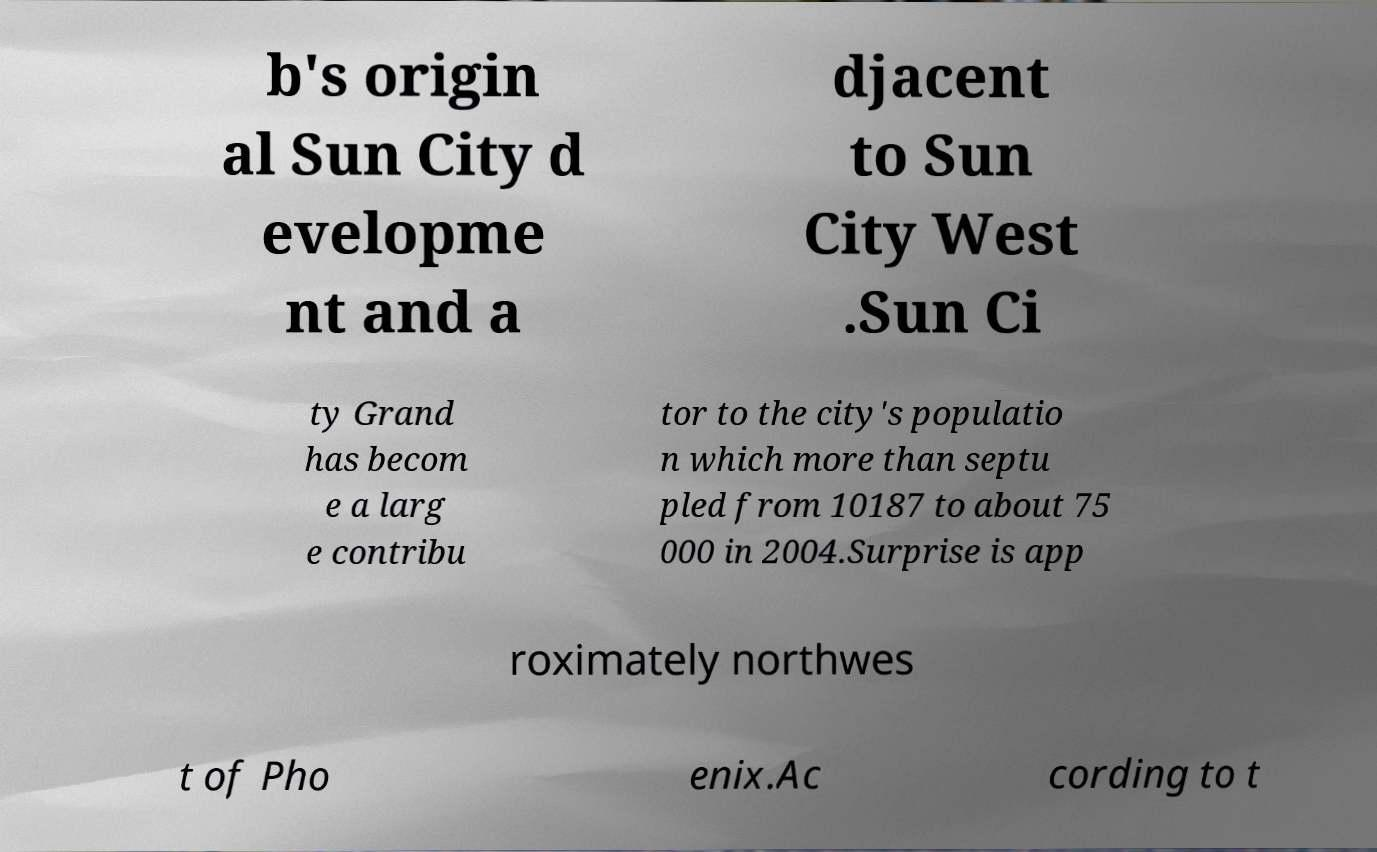What messages or text are displayed in this image? I need them in a readable, typed format. b's origin al Sun City d evelopme nt and a djacent to Sun City West .Sun Ci ty Grand has becom e a larg e contribu tor to the city's populatio n which more than septu pled from 10187 to about 75 000 in 2004.Surprise is app roximately northwes t of Pho enix.Ac cording to t 